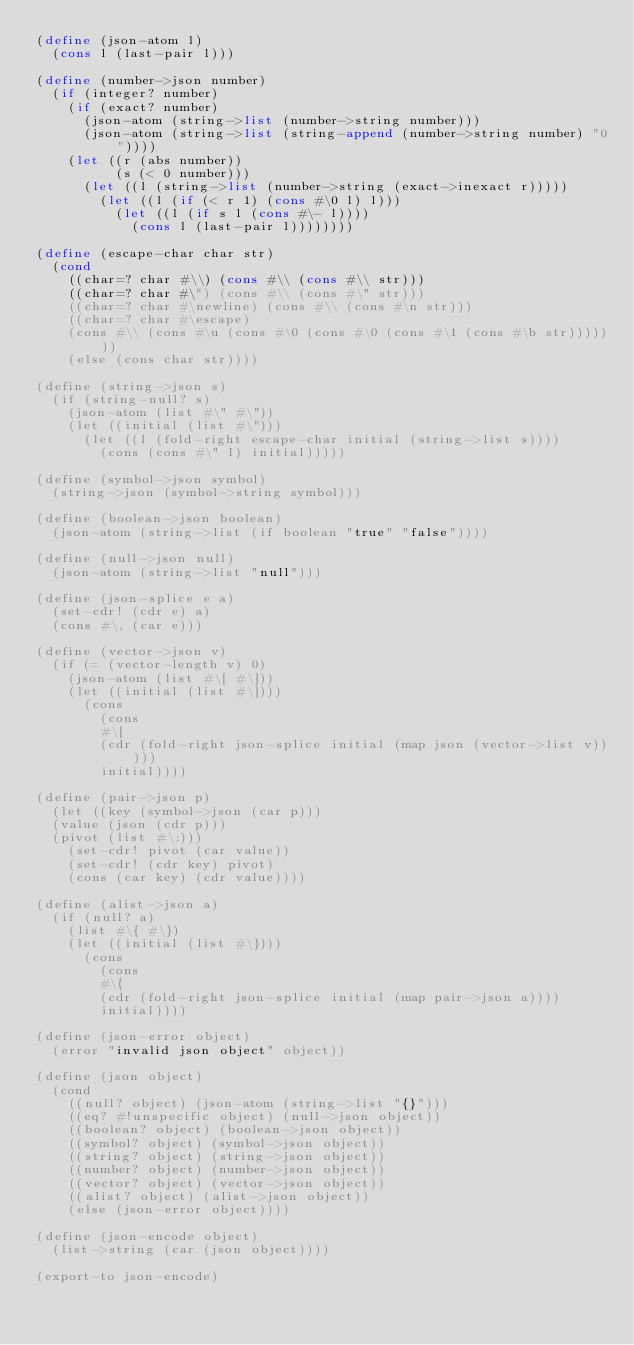Convert code to text. <code><loc_0><loc_0><loc_500><loc_500><_Scheme_>(define (json-atom l)
  (cons l (last-pair l)))

(define (number->json number)
  (if (integer? number)
    (if (exact? number)
      (json-atom (string->list (number->string number)))
      (json-atom (string->list (string-append (number->string number) "0"))))
    (let ((r (abs number))
          (s (< 0 number)))
      (let ((l (string->list (number->string (exact->inexact r)))))
        (let ((l (if (< r 1) (cons #\0 l) l)))
          (let ((l (if s l (cons #\- l))))
            (cons l (last-pair l))))))))

(define (escape-char char str)
  (cond
    ((char=? char #\\) (cons #\\ (cons #\\ str)))
    ((char=? char #\") (cons #\\ (cons #\" str)))
    ((char=? char #\newline) (cons #\\ (cons #\n str)))
    ((char=? char #\escape)
    (cons #\\ (cons #\u (cons #\0 (cons #\0 (cons #\1 (cons #\b str)))))))
    (else (cons char str))))

(define (string->json s)
  (if (string-null? s)
    (json-atom (list #\" #\"))
    (let ((initial (list #\")))
      (let ((l (fold-right escape-char initial (string->list s))))
        (cons (cons #\" l) initial)))))

(define (symbol->json symbol)
  (string->json (symbol->string symbol)))

(define (boolean->json boolean)
  (json-atom (string->list (if boolean "true" "false"))))

(define (null->json null)
  (json-atom (string->list "null")))

(define (json-splice e a)
  (set-cdr! (cdr e) a)
  (cons #\, (car e)))

(define (vector->json v)
  (if (= (vector-length v) 0)
    (json-atom (list #\[ #\]))
    (let ((initial (list #\])))
      (cons 
        (cons 
        #\[ 
        (cdr (fold-right json-splice initial (map json (vector->list v)))))
        initial))))

(define (pair->json p)
  (let ((key (symbol->json (car p)))
  (value (json (cdr p)))
  (pivot (list #\:)))
    (set-cdr! pivot (car value))
    (set-cdr! (cdr key) pivot)
    (cons (car key) (cdr value))))

(define (alist->json a)
  (if (null? a)
    (list #\{ #\})
    (let ((initial (list #\})))
      (cons
        (cons
        #\{
        (cdr (fold-right json-splice initial (map pair->json a))))
        initial))))

(define (json-error object)
  (error "invalid json object" object))

(define (json object)
  (cond
    ((null? object) (json-atom (string->list "{}")))
    ((eq? #!unspecific object) (null->json object))
    ((boolean? object) (boolean->json object))
    ((symbol? object) (symbol->json object))
    ((string? object) (string->json object))
    ((number? object) (number->json object))
    ((vector? object) (vector->json object))
    ((alist? object) (alist->json object))
    (else (json-error object))))

(define (json-encode object)
  (list->string (car (json object))))

(export-to json-encode)</code> 